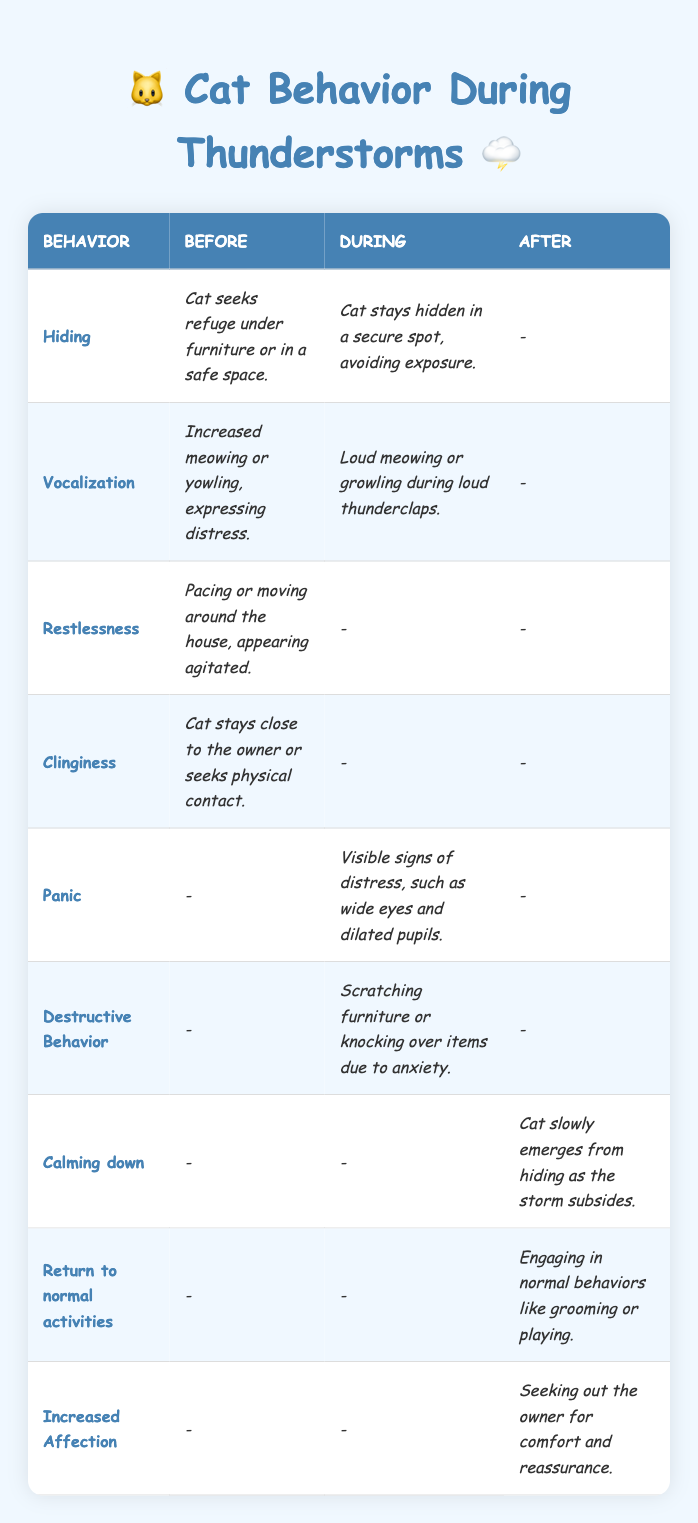What behavior does a cat typically exhibit before a thunderstorm? According to the table, the behaviors that cats typically exhibit before a thunderstorm include hiding, vocalization, restlessness, and clinginess.
Answer: Hiding, vocalization, restlessness, clinginess How does a cat react during a thunderstorm when it shows panic? The table indicates that during a thunderstorm, a cat shows visible signs of distress, such as wide eyes and dilated pupils, which is described as panic.
Answer: Visible signs of distress, wide eyes, dilated pupils True or False: A cat engages in normal activities right after a thunderstorm. The table shows that after a storm, a cat returns to normal activities such as grooming or playing, so the statement is true.
Answer: True What are the three stages of feline behaviors related to thunderstorms listed in the table? The behaviors are categorized into three stages: Before, During, and After thunderstorms according to the table.
Answer: Before, During, After Which behavior is associated with increased affection after a thunderstorm? The table specifies that after a thunderstorm, a cat seeks out the owner for comfort and reassurance, indicating increased affection.
Answer: Seeking out the owner for comfort and reassurance How many unique behaviors are listed for cats during thunderstorms that show distress? Three behaviors are listed under the "During" stage that show distress: vocalization, panic, and destructive behavior.
Answer: Three behaviors What is the main difference between a cat's behavior before and during a thunderstorm in terms of vocalization? Before a storm, the vocalization is increased meowing or yowling, expressing distress, while during the storm, it involves loud meowing or growling specifically during thunderclaps.
Answer: Increased meowing before; loud meowing during What might a cat do immediately after a thunderstorm subsides in terms of behavior? According to the table, once the storm subsides, a cat may start calming down, emerging from hiding, and return to normal activities like grooming and playing.
Answer: Calming down, returning to normal activities How would you describe the behavior of a cat who shows clinginess before a storm? The table explains that clinginess before a storm involves a cat staying close to the owner or seeking physical contact, indicating a need for reassurance.
Answer: Staying close to the owner or seeking physical contact 